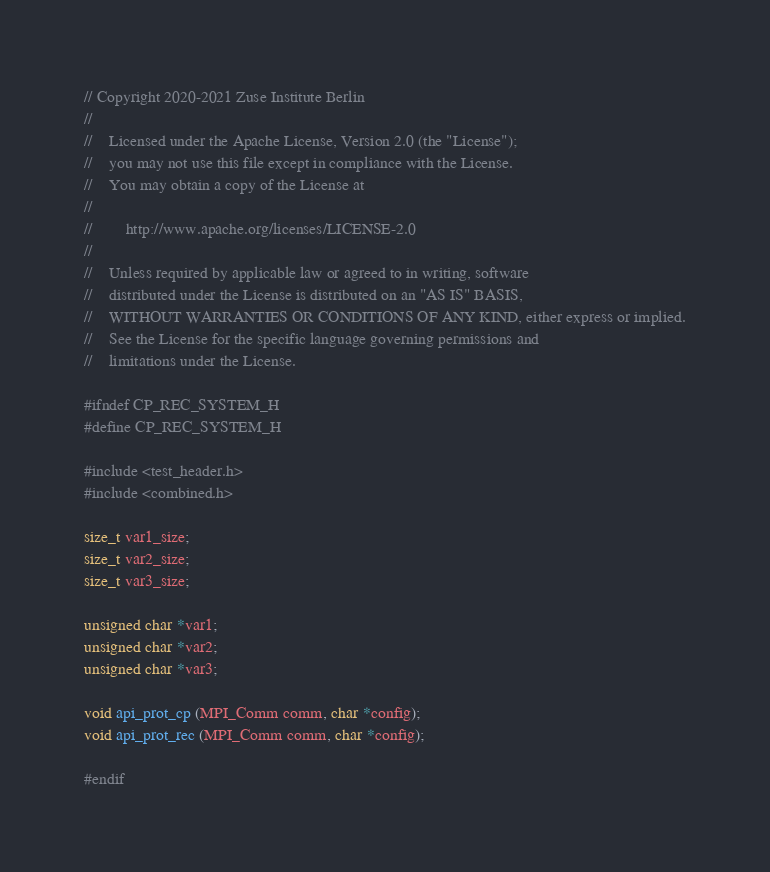Convert code to text. <code><loc_0><loc_0><loc_500><loc_500><_C_>// Copyright 2020-2021 Zuse Institute Berlin
//
//    Licensed under the Apache License, Version 2.0 (the "License");
//    you may not use this file except in compliance with the License.
//    You may obtain a copy of the License at
//
//        http://www.apache.org/licenses/LICENSE-2.0
//
//    Unless required by applicable law or agreed to in writing, software
//    distributed under the License is distributed on an "AS IS" BASIS,
//    WITHOUT WARRANTIES OR CONDITIONS OF ANY KIND, either express or implied.
//    See the License for the specific language governing permissions and
//    limitations under the License.

#ifndef CP_REC_SYSTEM_H
#define CP_REC_SYSTEM_H

#include <test_header.h>
#include <combined.h>

size_t var1_size;
size_t var2_size;
size_t var3_size;

unsigned char *var1;
unsigned char *var2;
unsigned char *var3;

void api_prot_cp (MPI_Comm comm, char *config);
void api_prot_rec (MPI_Comm comm, char *config);

#endif
</code> 